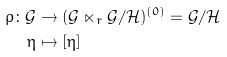Convert formula to latex. <formula><loc_0><loc_0><loc_500><loc_500>\rho \colon \mathcal { G } & \rightarrow ( \mathcal { G } \ltimes _ { r } \mathcal { G } / \mathcal { H } ) ^ { ( 0 ) } = \mathcal { G } / \mathcal { H } \\ \eta & \mapsto [ \eta ]</formula> 